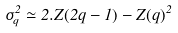<formula> <loc_0><loc_0><loc_500><loc_500>\sigma _ { q } ^ { 2 } \simeq { 2 . Z ( 2 q - 1 ) - Z ( q ) ^ { 2 } }</formula> 